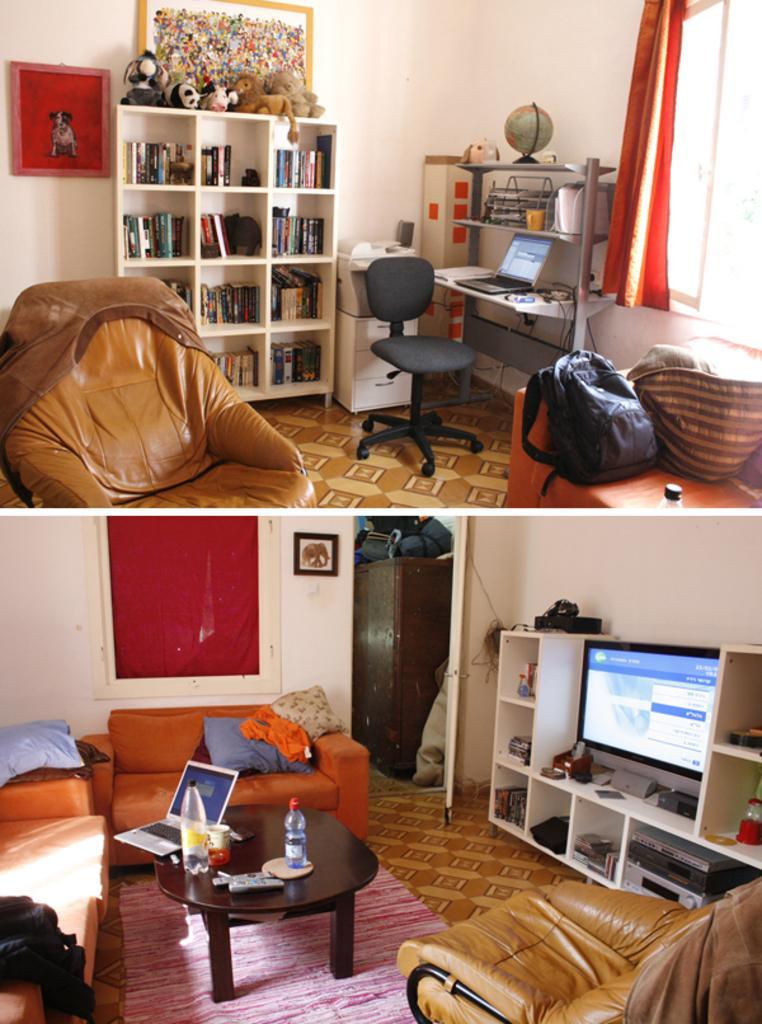Please provide a concise description of this image. A picture is taken inside the room. In this image we can see on right side a television,bag,laptop,window,curtain,wall which is in white color. In middle there is a shelf on shelf we can see some books and toys, on left side there is a photo frame,couch at bottom there is a mat. 